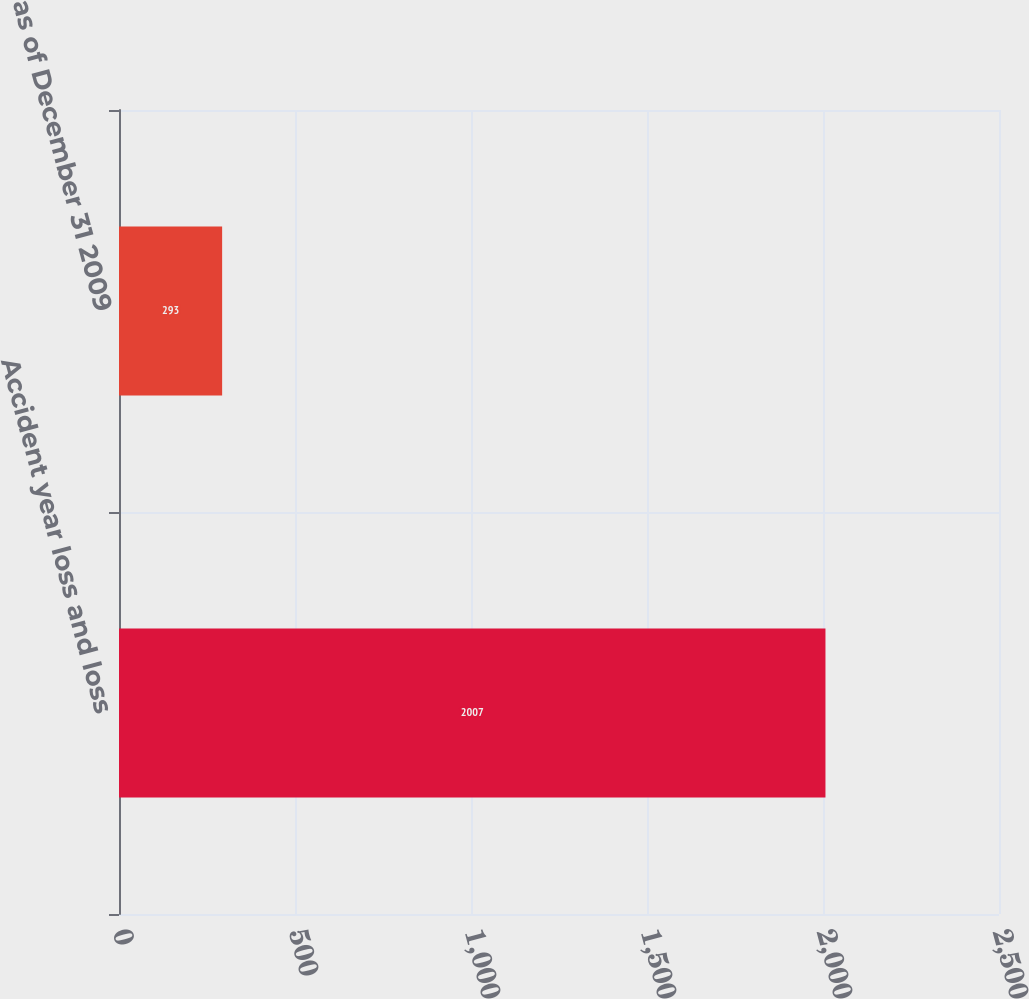<chart> <loc_0><loc_0><loc_500><loc_500><bar_chart><fcel>Accident year loss and loss<fcel>as of December 31 2009<nl><fcel>2007<fcel>293<nl></chart> 